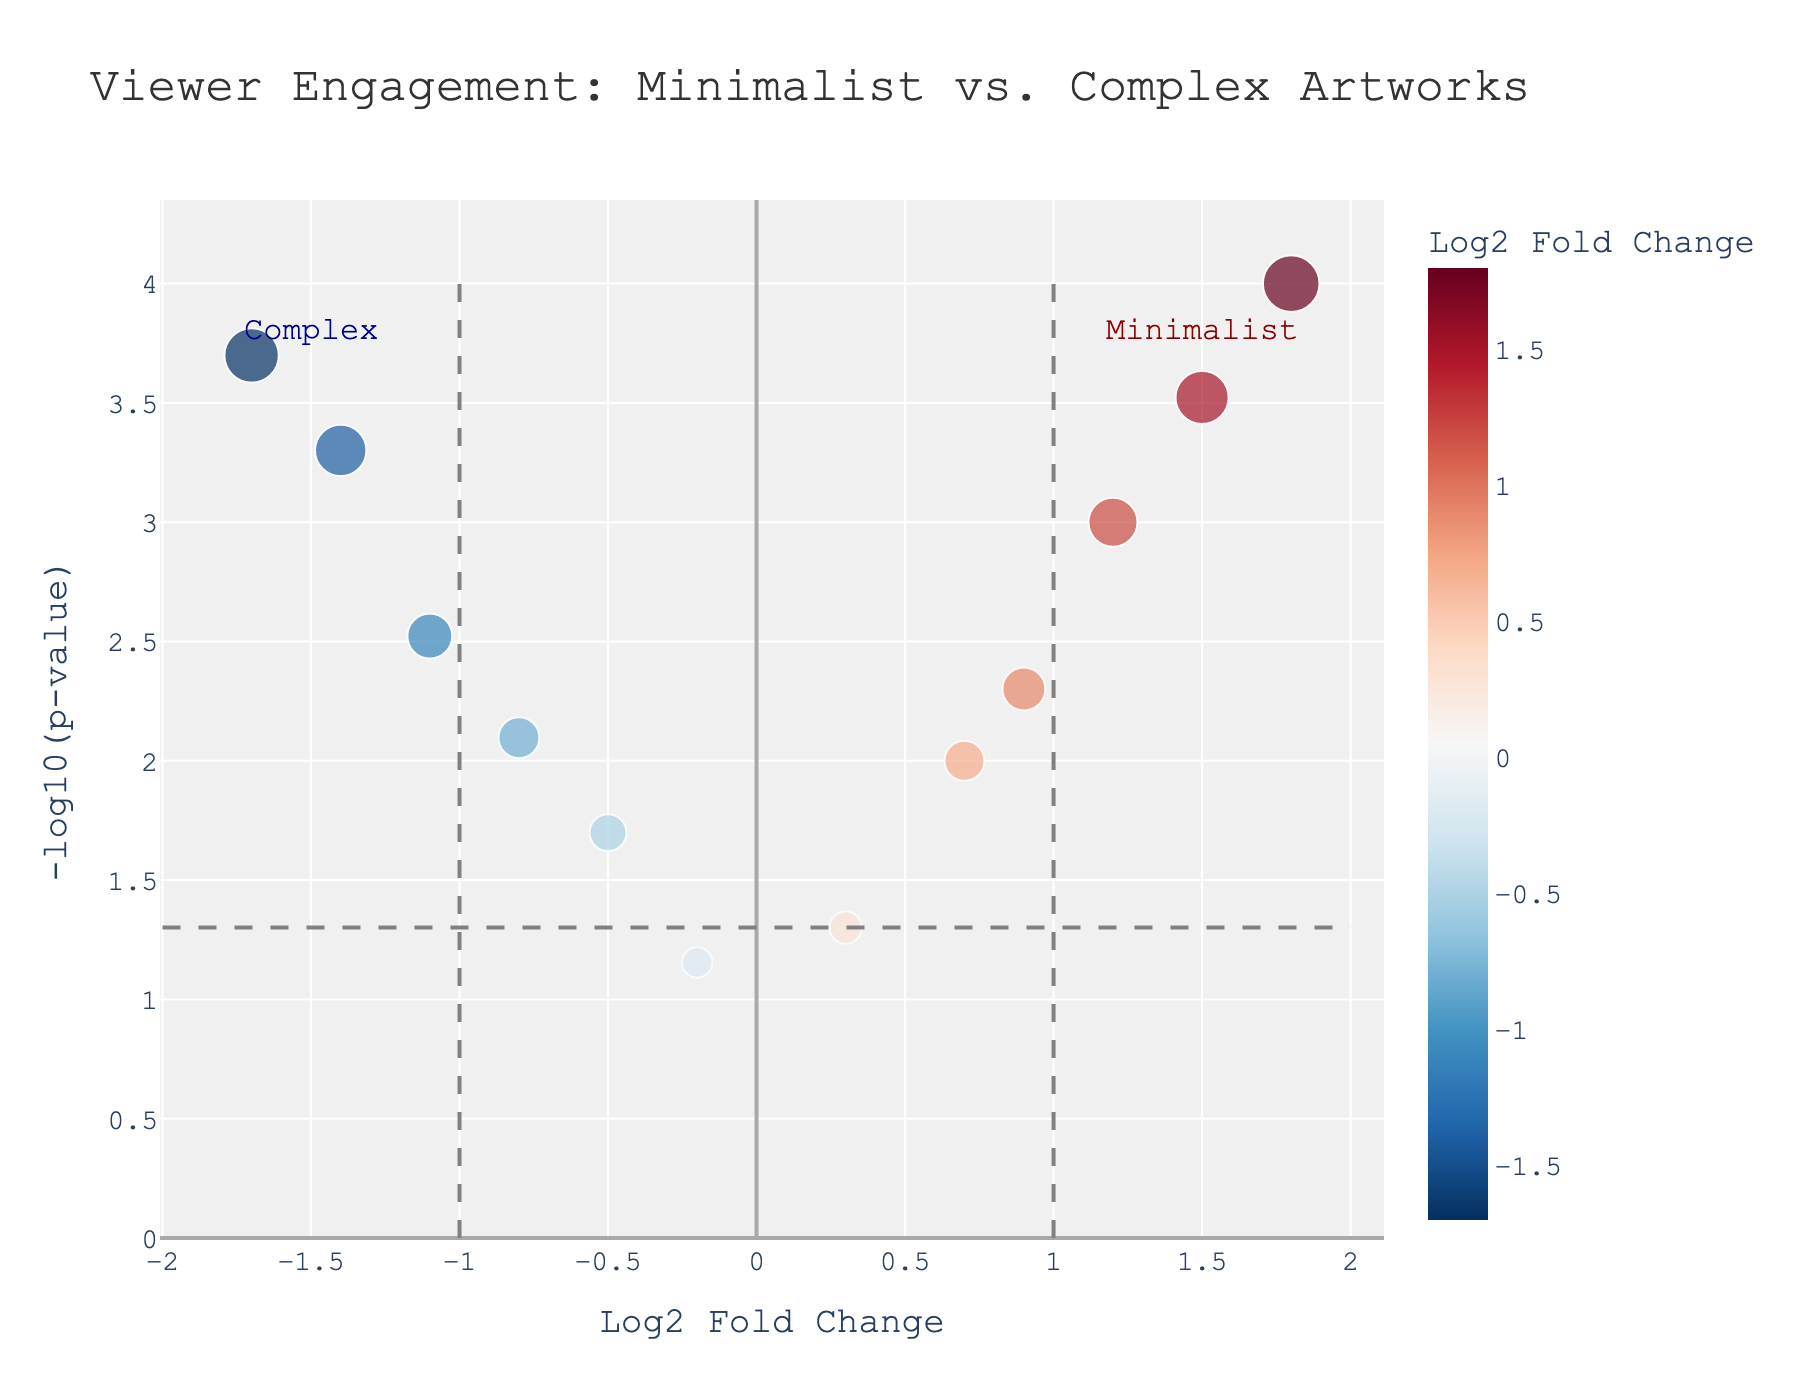What is the title of the plot? The title is usually displayed at the top of the figure, summarizing the main focus of the plot. In this plot, the title is located centrally at the top.
Answer: Viewer Engagement: Minimalist vs. Complex Artworks How many artworks have a negative Log2 Fold Change? To find this, count the data points that fall to the left of the vertical line at Log2 Fold Change = 0. In the plot, these points have negative values on the x-axis.
Answer: 6 Which artwork has the highest viewer engagement among minimalist artworks? The artwork with the highest viewer engagement among minimalist artworks will have the highest vertical distance (highest -log10(p-value)) and a positive Log2 Fold Change. By inspecting the plot, look for the highest point on the right side (positive x-axis).
Answer: Rothko's Orange and Yellow What is the position of the horizontal line for the p-value threshold in terms of -log10(p)? The horizontal threshold line corresponds to a p-value of 0.05. Calculate -log10(0.05) to find its position on the y-axis. The horizontal line indicates statistical significance.
Answer: 1.301 How does "Salvador Dali's The Persistence of Memory" compare to "Rothko's Orange and Yellow" in terms of viewer engagement? To compare these artworks, observe their respective positions on the plot. "The Persistence of Memory" is on the left with negative Log2 Fold Change and high -log10(p), while "Rothko's Orange and Yellow" is on the right with positive Log2 Fold Change and high -log10(p). Thus, viewers engage more with minimalist than with complex artworks by these two artists.
Answer: Not as engaging Which artwork has the lowest significance level among complex artworks, and what is its p-value? Identify the artwork from complex compositions that has the smallest -log10(p) value on the plot. Invert the -log10(p) to get the p-value. This will show the lowest significance level.
Answer: Kelly's Colors for a Large Wall, 0.07 What is the difference in Log2 Fold Change between "Willem de Kooning's Woman I" and "Agnes Martin's The Tree"? Subtract the Log2 Fold Change of "Willem de Kooning's Woman I" from that of "Agnes Martin's The Tree." This indicates the difference in viewer engagement between the two artworks.
Answer: 1.7 Which artwork has the highest -log10(p) among complex artworks? To determine this, find the artwork situated highest on the y-axis but to the left of the vertical line at Log2 Fold Change = 0. This represents the artwork with the lowest p-value among complex artworks.
Answer: Dali's The Persistence of Memory How many artworks are statistically significant (p < 0.05)? Count the data points that are above the horizontal threshold line at -log10(p) = 1.301 since these represent significant p-values.
Answer: 9 What can you infer about the overall viewer engagement with minimalist vs. complex artworks? Observe the general distribution of the points. Most minimalist artworks are on the right with higher Log2 Fold Change, indicating greater engagement, while most complex artworks are on the left with lower values, suggesting less engagement.
Answer: Minimalist more engaging 